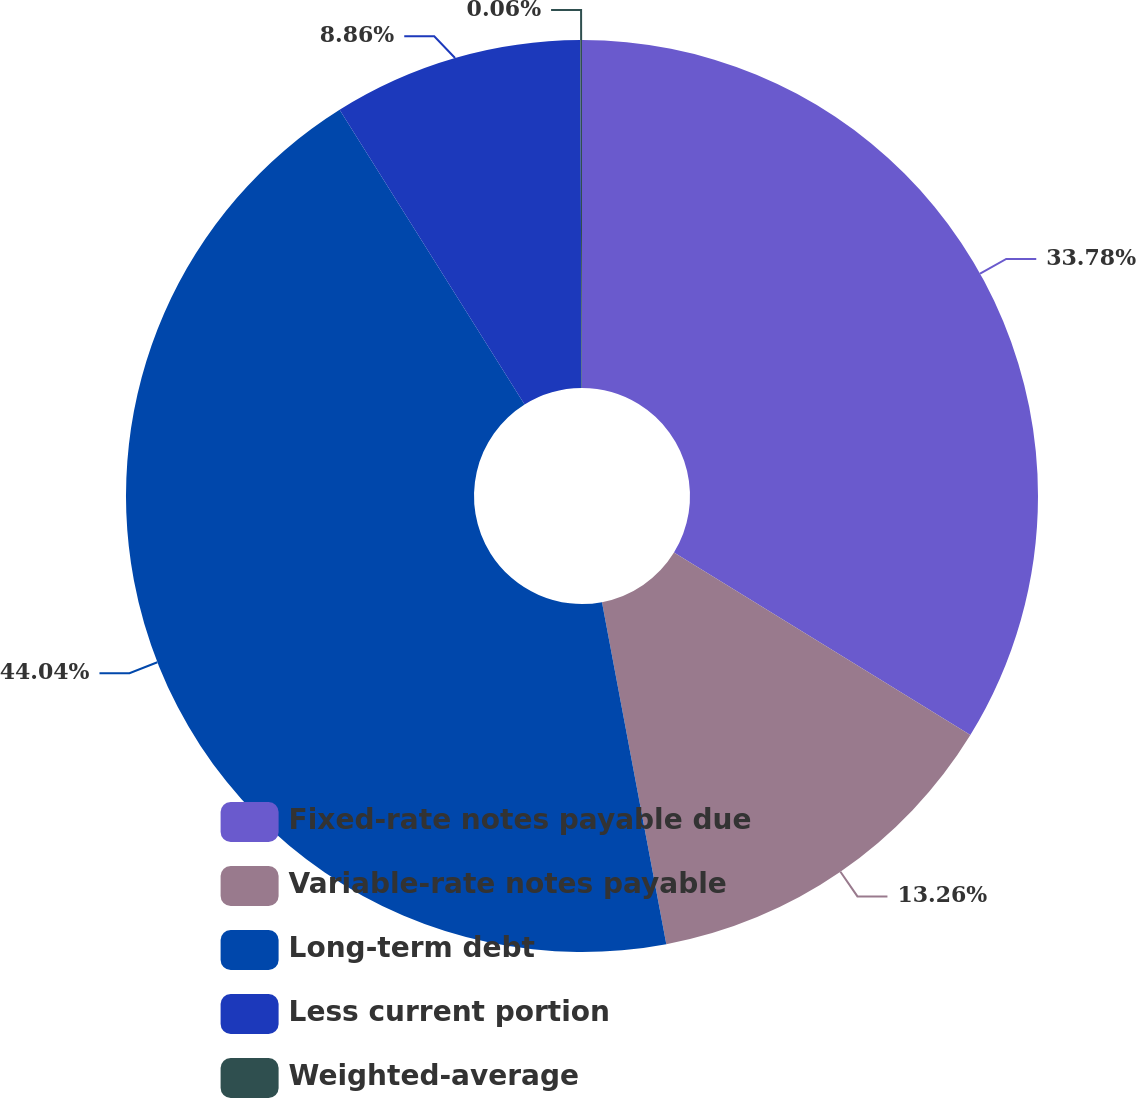<chart> <loc_0><loc_0><loc_500><loc_500><pie_chart><fcel>Fixed-rate notes payable due<fcel>Variable-rate notes payable<fcel>Long-term debt<fcel>Less current portion<fcel>Weighted-average<nl><fcel>33.78%<fcel>13.26%<fcel>44.04%<fcel>8.86%<fcel>0.06%<nl></chart> 